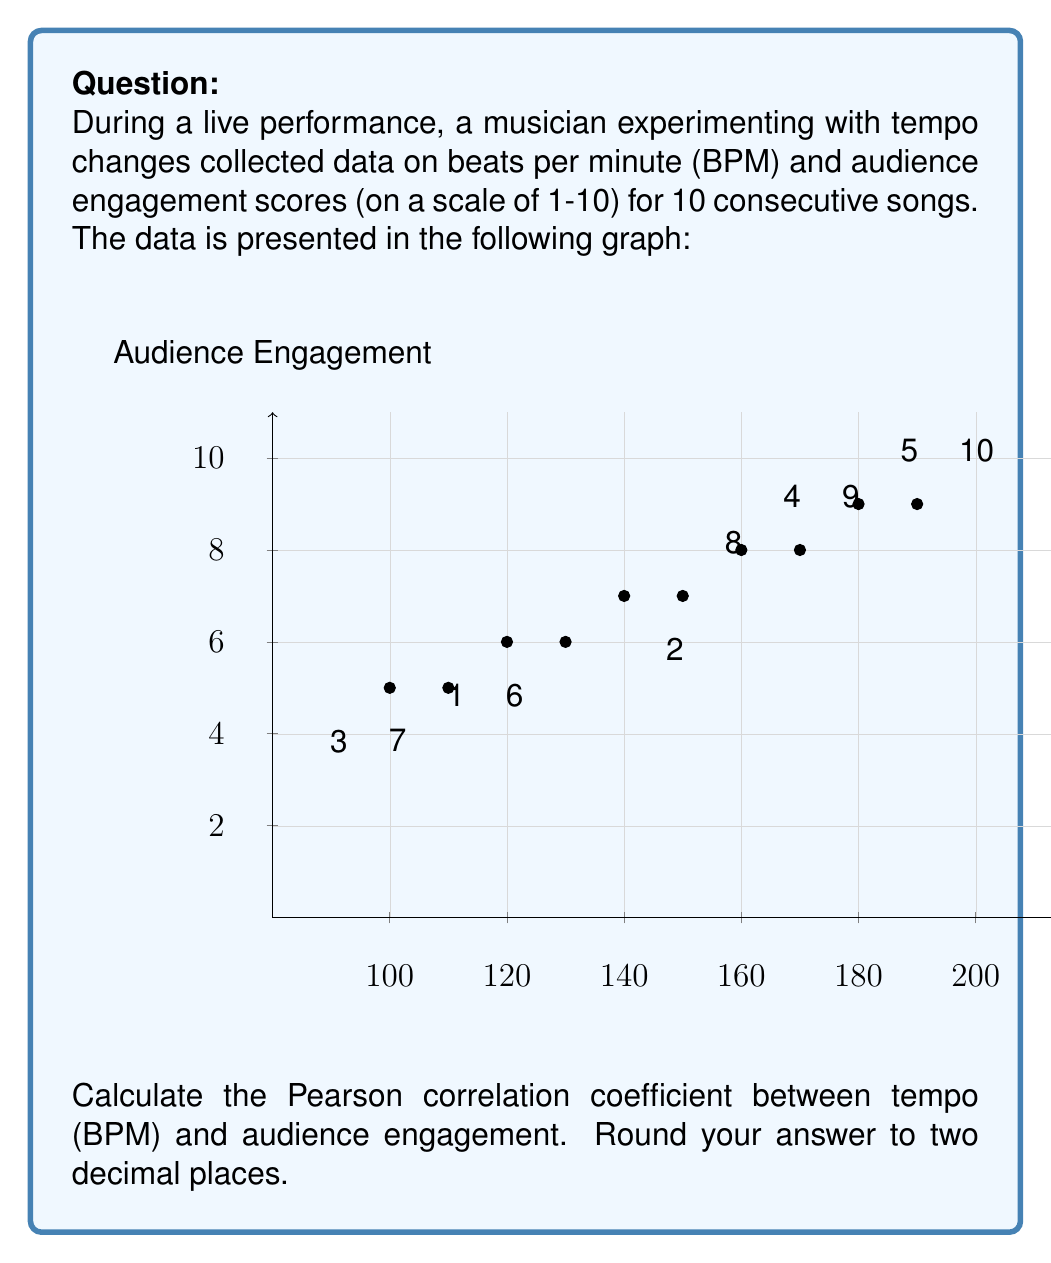Show me your answer to this math problem. To calculate the Pearson correlation coefficient, we'll use the formula:

$$r = \frac{\sum_{i=1}^{n} (x_i - \bar{x})(y_i - \bar{y})}{\sqrt{\sum_{i=1}^{n} (x_i - \bar{x})^2} \sqrt{\sum_{i=1}^{n} (y_i - \bar{y})^2}}$$

Where:
$x_i$ are the BPM values
$y_i$ are the audience engagement scores
$\bar{x}$ is the mean of BPM values
$\bar{y}$ is the mean of audience engagement scores

Step 1: Calculate means
$\bar{x} = \frac{120 + 140 + 100 + 160 + 180 + 130 + 110 + 150 + 170 + 190}{10} = 145$
$\bar{y} = \frac{6 + 7 + 5 + 8 + 9 + 6 + 5 + 7 + 8 + 9}{10} = 7$

Step 2: Calculate $(x_i - \bar{x})$, $(y_i - \bar{y})$, $(x_i - \bar{x})^2$, $(y_i - \bar{y})^2$, and $(x_i - \bar{x})(y_i - \bar{y})$

Step 3: Sum up the calculated values
$\sum (x_i - \bar{x})(y_i - \bar{y}) = 825$
$\sum (x_i - \bar{x})^2 = 11050$
$\sum (y_i - \bar{y})^2 = 18$

Step 4: Apply the formula
$r = \frac{825}{\sqrt{11050} \sqrt{18}} = \frac{825}{\sqrt{198900}} = \frac{825}{446.0} = 0.8497$

Step 5: Round to two decimal places
$r \approx 0.85$
Answer: 0.85 